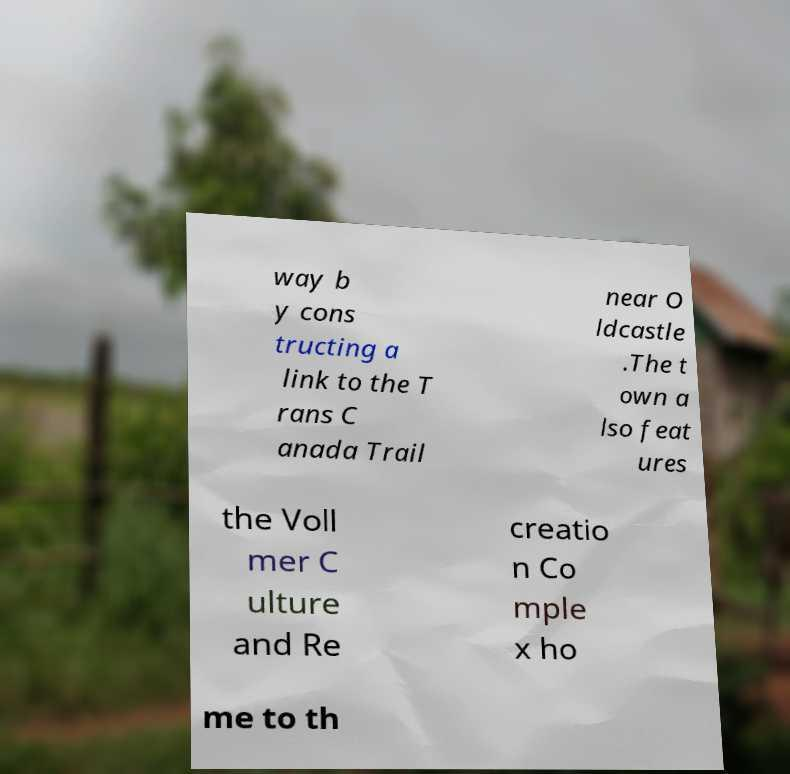Can you accurately transcribe the text from the provided image for me? way b y cons tructing a link to the T rans C anada Trail near O ldcastle .The t own a lso feat ures the Voll mer C ulture and Re creatio n Co mple x ho me to th 